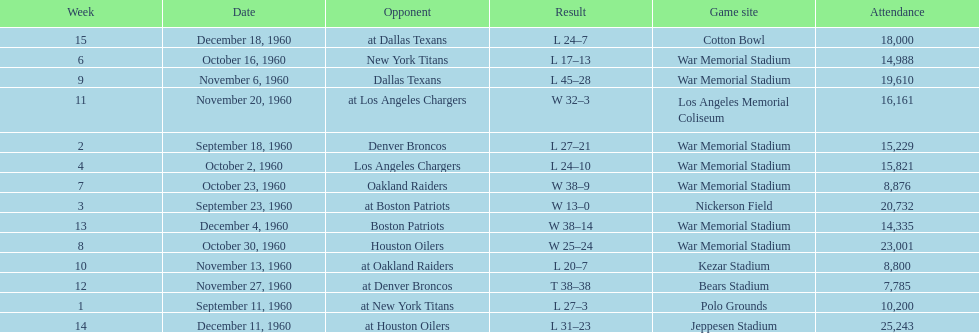How many games had an attendance of 10,000 at most? 11. 